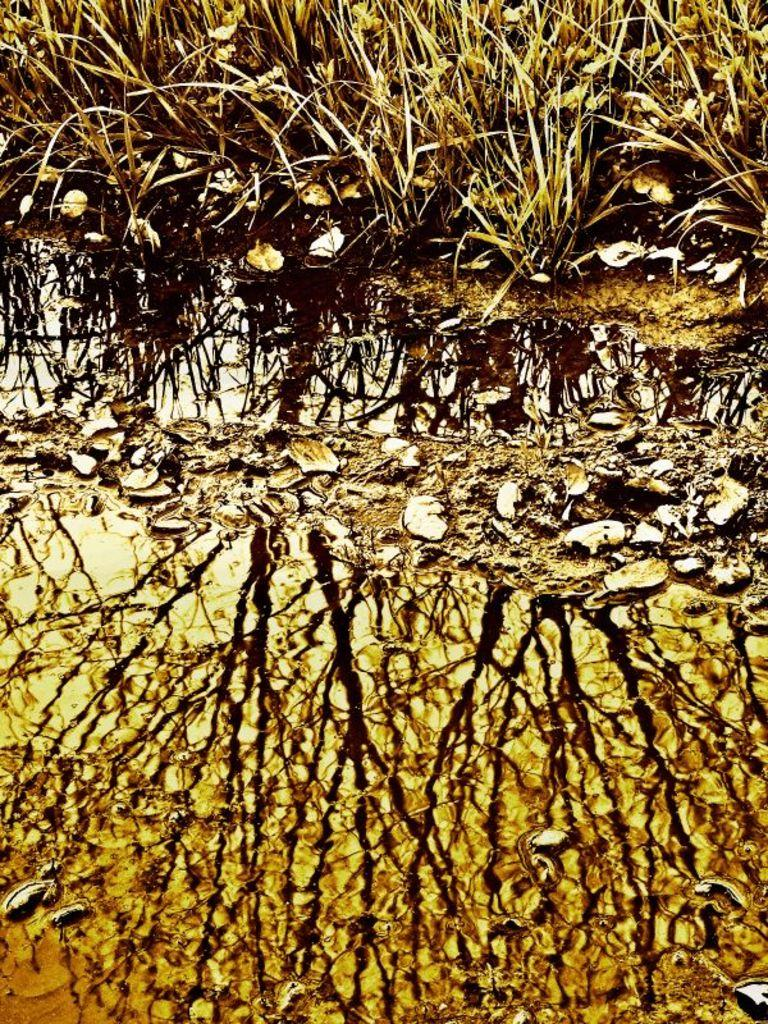What is visible in the image? There is water visible in the image. What else can be seen on the ground in the image? There are leaves on the ground in the image. What is visible in the background of the image? There are plants in the background of the image. What type of drain is visible in the image? There is no drain present in the image. How many fangs can be seen on the plants in the image? Plants do not have fangs, and there are no animals with fangs visible in the image. 